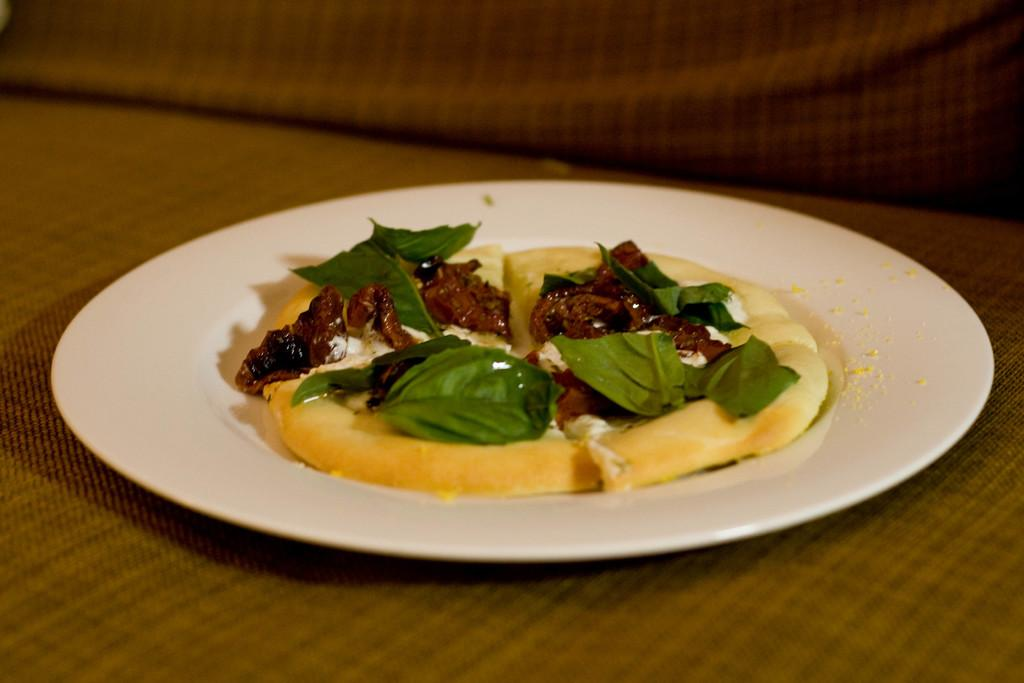What is the color of the surface in the image? The surface in the image is brown. What is placed on the brown surface? There is a white plate on the brown surface. What is on the white plate? There is a food item in the plate. What can be seen on the food item? There are green leaves on the food item. How many maids are present at the party in the image? There is no party or maid present in the image. What is the level of pollution in the image? There is no indication of pollution in the image. 